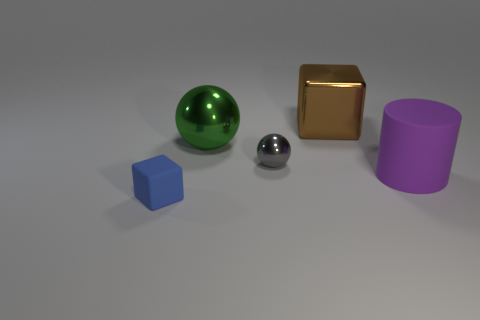What could these objects represent in an abstract sense? These objects, with their different shapes and colors, could represent diversity and uniqueness. Each object stands out in its own right, similar to how individuals in a society bring their unique characteristics to the whole. It might also be a nod to the diversity of elements in a well-balanced system, with each shape symbolizing a different component working in harmony. 